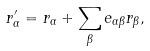Convert formula to latex. <formula><loc_0><loc_0><loc_500><loc_500>r ^ { \prime } _ { \alpha } = r _ { \alpha } + \sum _ { \beta } e _ { \alpha \beta } r _ { \beta } ,</formula> 